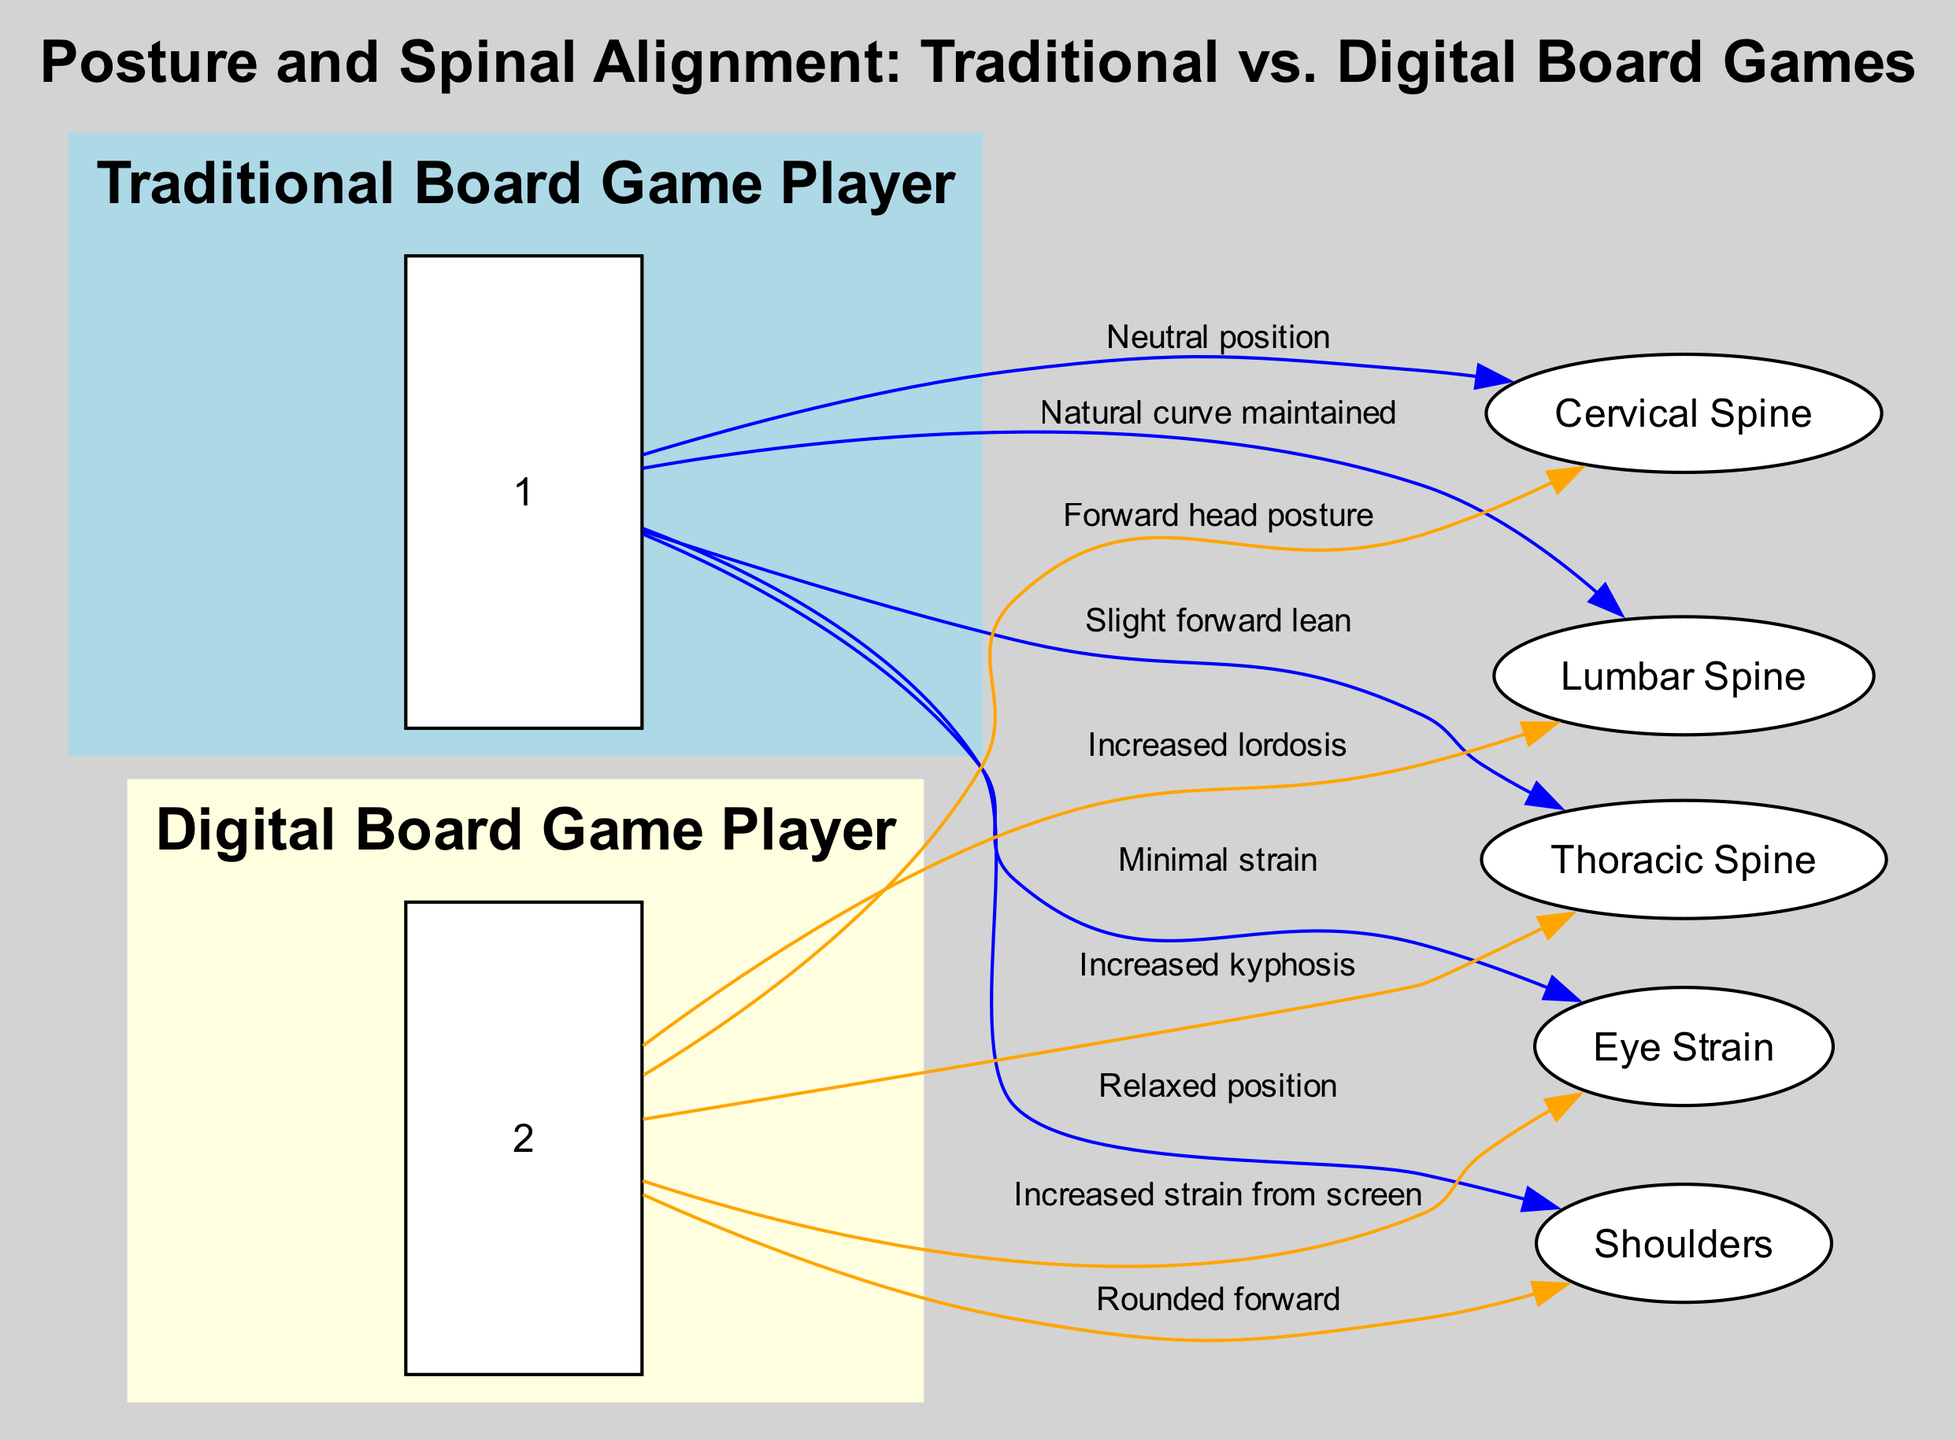What type of posture is associated with traditional board game players in the cervical spine? The diagram shows that traditional board game players maintain a "Neutral position" in the cervical spine, which indicates a straight alignment without forward head posture.
Answer: Neutral position What is the relationship between digital board game players and eye strain? The diagram indicates a direct connection where digital board game players experience "Increased strain from screen," showing a negative effect related to prolonged screen usage.
Answer: Increased strain from screen How many nodes are present in the diagram? By counting, there are a total of 7 nodes depicted in the diagram, including both the types of players and the spinal components.
Answer: 7 What posture do traditional board game players exhibit in the lumbar spine? The diagram specifies that traditional board game players have an "Natural curve maintained" in the lumbar spine, which is an optimal spinal alignment.
Answer: Natural curve maintained What is the indicated shoulder position for digital board game players? According to the diagram, digital board game players have a "Rounded forward" position for their shoulders, suggesting a common issue related to bad posture from screens.
Answer: Rounded forward What does the diagram suggest about the thoracic spine posture of traditional board game players? The diagram illustrates that traditional board game players have a "Slight forward lean" in the thoracic spine, indicating a more relaxed and less stressed postural alignment.
Answer: Slight forward lean Compare the posture of digital board game players to traditional ones regarding lumbar spine alignment. The diagram contrasts the two by stating that digital game players have "Increased lordosis" while traditional players maintain a "Natural curve," showing a significant difference in spinal health.
Answer: Increased lordosis What does the edge label "Increased kyphosis" refer to in the context of digital board game players? This label connects digital board game players to the thoracic spine indicating that they exhibit an abnormal curvature leading to a more pronounced kyphotic posture compared to traditional gamers.
Answer: Increased kyphosis 